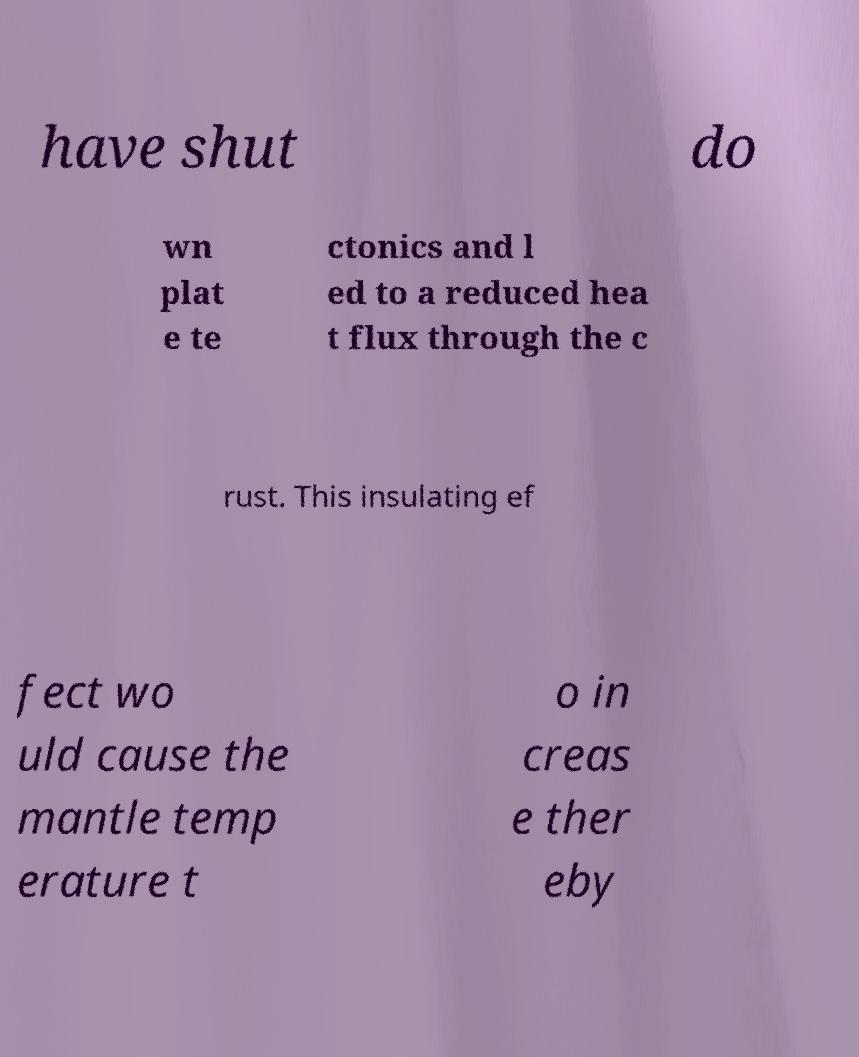Please identify and transcribe the text found in this image. have shut do wn plat e te ctonics and l ed to a reduced hea t flux through the c rust. This insulating ef fect wo uld cause the mantle temp erature t o in creas e ther eby 